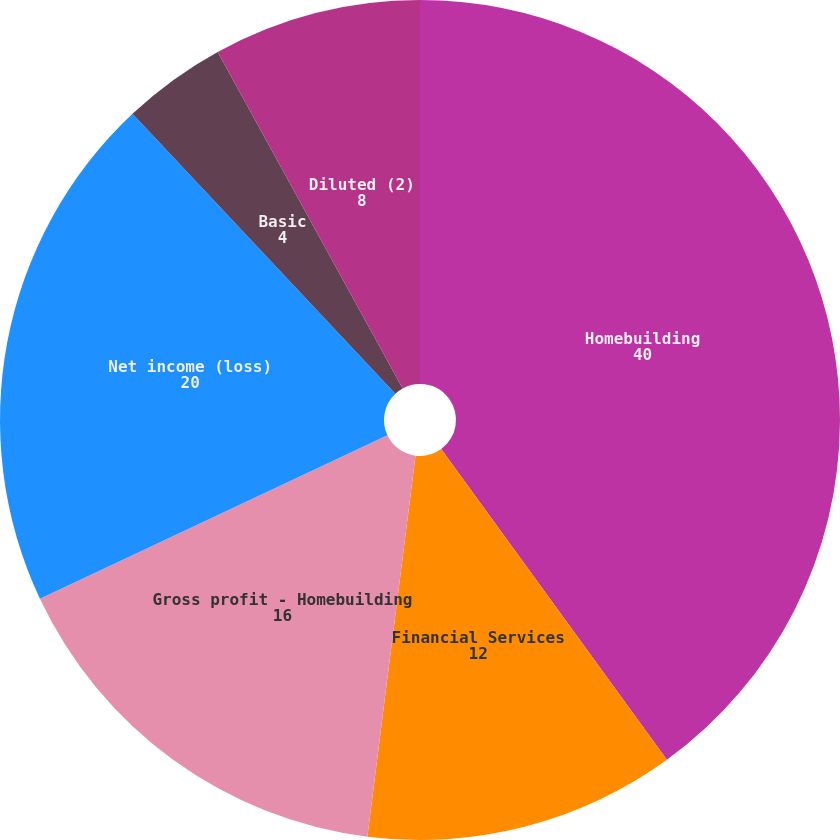Convert chart. <chart><loc_0><loc_0><loc_500><loc_500><pie_chart><fcel>Homebuilding<fcel>Financial Services<fcel>Gross profit - Homebuilding<fcel>Net income (loss)<fcel>Basic<fcel>Diluted (2)<fcel>Cash dividends declared per<nl><fcel>40.0%<fcel>12.0%<fcel>16.0%<fcel>20.0%<fcel>4.0%<fcel>8.0%<fcel>0.0%<nl></chart> 